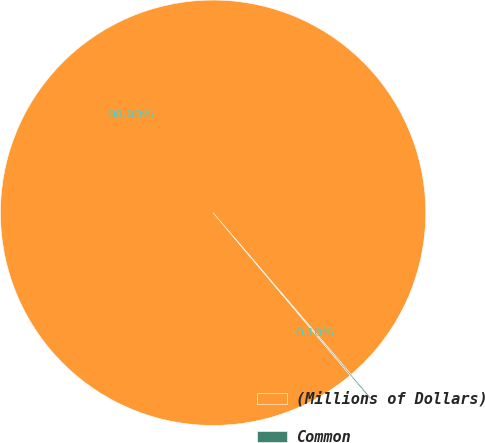Convert chart to OTSL. <chart><loc_0><loc_0><loc_500><loc_500><pie_chart><fcel>(Millions of Dollars)<fcel>Common<nl><fcel>99.9%<fcel>0.1%<nl></chart> 